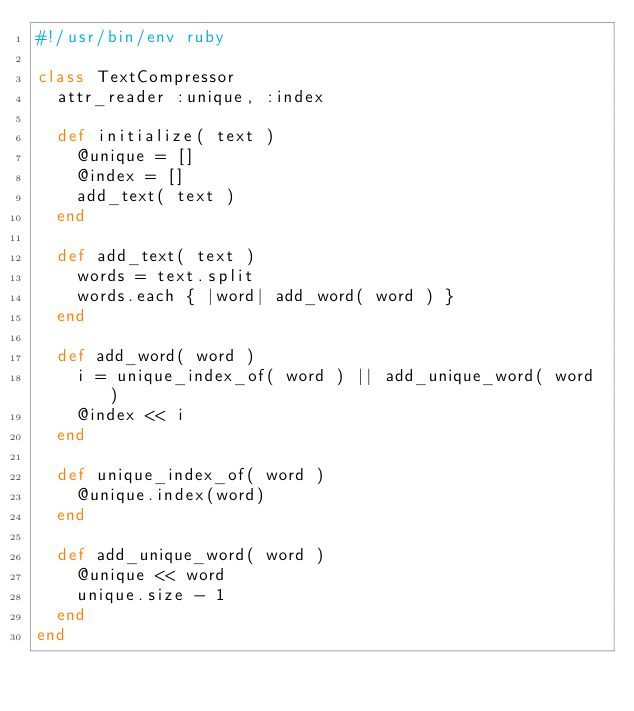<code> <loc_0><loc_0><loc_500><loc_500><_Ruby_>#!/usr/bin/env ruby

class TextCompressor
  attr_reader :unique, :index

  def initialize( text )
    @unique = []
    @index = []
    add_text( text )
  end

  def add_text( text )
    words = text.split
    words.each { |word| add_word( word ) }
  end

  def add_word( word )
    i = unique_index_of( word ) || add_unique_word( word )
    @index << i
  end

  def unique_index_of( word )
    @unique.index(word)
  end

  def add_unique_word( word )
    @unique << word
    unique.size - 1
  end
end
</code> 